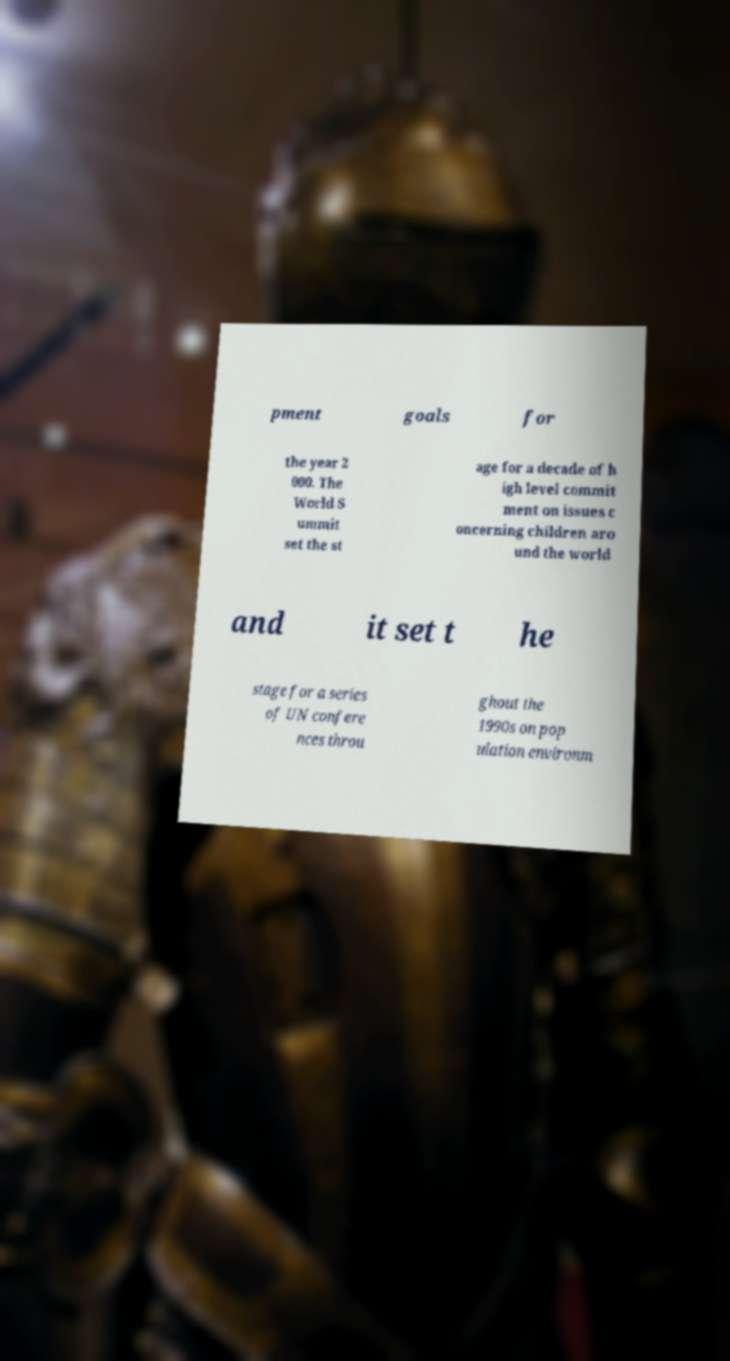Could you assist in decoding the text presented in this image and type it out clearly? pment goals for the year 2 000. The World S ummit set the st age for a decade of h igh level commit ment on issues c oncerning children aro und the world and it set t he stage for a series of UN confere nces throu ghout the 1990s on pop ulation environm 